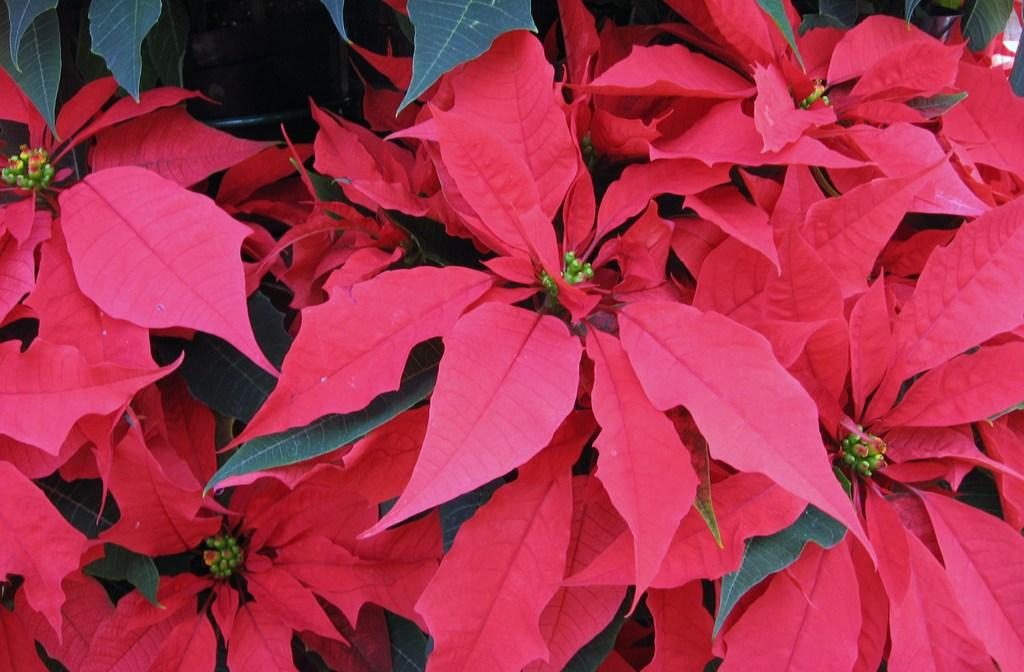What type of objects are present in the image? The image contains leaves of plants. What color are the leaves? The leaves are green and pink in color. How many guns can be seen in the image? There are no guns present in the image; it features leaves of plants. What type of selection process is depicted in the image? There is no selection process depicted in the image; it features leaves of plants. 